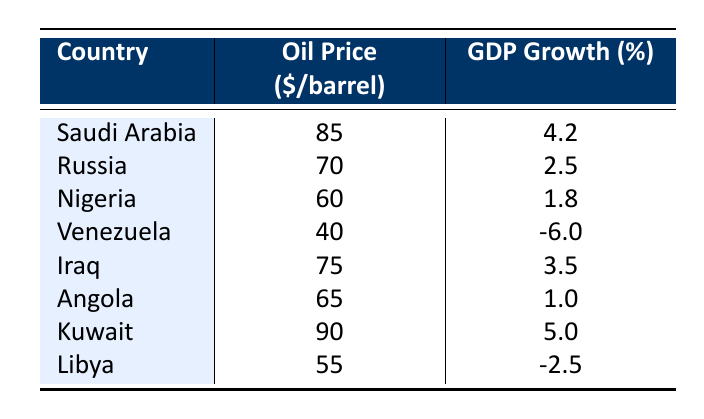What is the GDP growth of Nigeria? According to the table, the GDP growth for Nigeria is listed as 1.8%.
Answer: 1.8% Which country has the highest oil price? The table shows that Kuwait has the highest oil price at 90 dollars per barrel.
Answer: Kuwait What is the difference in GDP growth between Saudi Arabia and Iraq? Saudi Arabia has a GDP growth of 4.2% while Iraq has a GDP growth of 3.5%. The difference is calculated as 4.2 - 3.5 = 0.7%.
Answer: 0.7% Is the GDP growth in Venezuela positive? The table indicates that Venezuela has a GDP growth of -6.0%, which is negative.
Answer: No What is the average oil price among the listed countries? To find the average oil price, sum all the oil prices: (85 + 70 + 60 + 40 + 75 + 65 + 90 + 55) = 570. There are 8 countries, so the average is 570 / 8 = 71.25 dollars per barrel.
Answer: 71.25 Which countries have a GDP growth greater than 2%? From the table, the countries with GDP growth greater than 2% are Saudi Arabia (4.2%), Russia (2.5%), and Kuwait (5.0%).
Answer: Saudi Arabia, Russia, Kuwait What is the highest GDP growth value in the table? The GDP growth values in the table show that the highest value is 5.0%, attributed to Kuwait.
Answer: 5.0% Is Angola's oil price less than the average oil price? The average oil price was calculated to be 71.25 dollars per barrel, and Angola's oil price is 65 dollars per barrel, which is less than the average.
Answer: Yes What is the sum of GDP growths for Nigeria, Venezuela, and Angola? The GDP growths for these countries are 1.8% (Nigeria), -6.0% (Venezuela), and 1.0% (Angola). The sum is 1.8 + (-6.0) + 1.0 = -3.2%.
Answer: -3.2% 